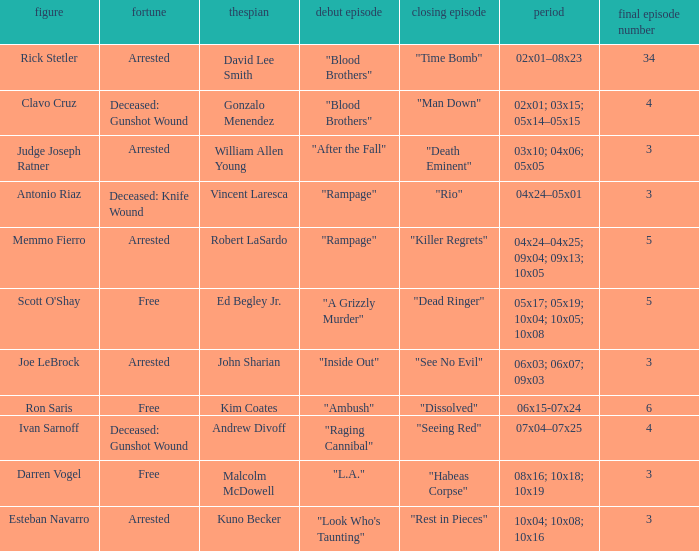What's the first epbeingode with final epbeingode being "rio" "Rampage". 